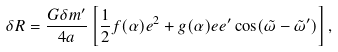Convert formula to latex. <formula><loc_0><loc_0><loc_500><loc_500>\delta R = \frac { G \delta m ^ { \prime } } { 4 a } \left [ \frac { 1 } { 2 } f ( \alpha ) e ^ { 2 } + g ( \alpha ) e e ^ { \prime } \cos ( \tilde { \omega } - \tilde { \omega } ^ { \prime } ) \right ] ,</formula> 